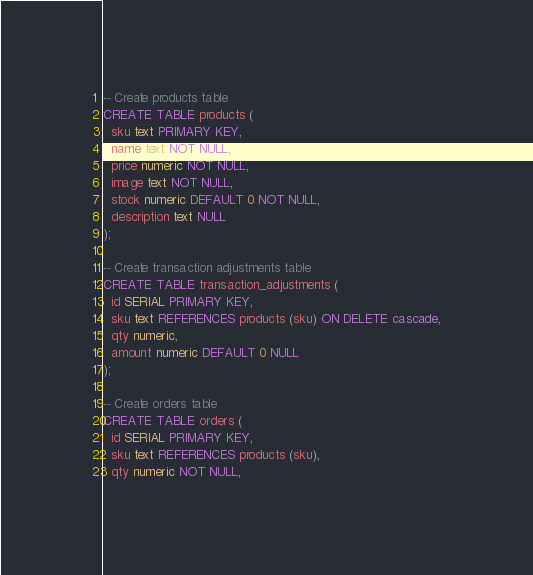Convert code to text. <code><loc_0><loc_0><loc_500><loc_500><_SQL_>-- Create products table
CREATE TABLE products (
  sku text PRIMARY KEY,
  name text NOT NULL,
  price numeric NOT NULL,
  image text NOT NULL,
  stock numeric DEFAULT 0 NOT NULL,
  description text NULL
);

-- Create transaction adjustments table
CREATE TABLE transaction_adjustments (
  id SERIAL PRIMARY KEY,
  sku text REFERENCES products (sku) ON DELETE cascade,
  qty numeric,
  amount numeric DEFAULT 0 NULL
);

-- Create orders table
CREATE TABLE orders (
  id SERIAL PRIMARY KEY,
  sku text REFERENCES products (sku),
  qty numeric NOT NULL,</code> 